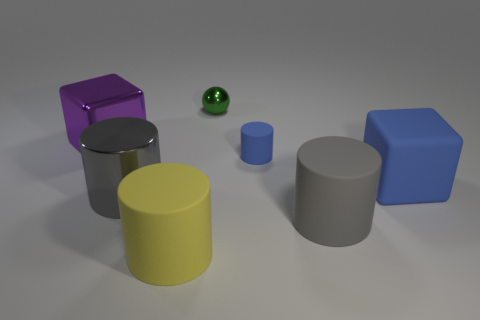Subtract all purple cylinders. Subtract all purple spheres. How many cylinders are left? 4 Add 2 blue cylinders. How many objects exist? 9 Subtract all spheres. How many objects are left? 6 Add 5 large blue matte blocks. How many large blue matte blocks are left? 6 Add 4 tiny green shiny objects. How many tiny green shiny objects exist? 5 Subtract 0 green cylinders. How many objects are left? 7 Subtract all gray things. Subtract all big shiny cubes. How many objects are left? 4 